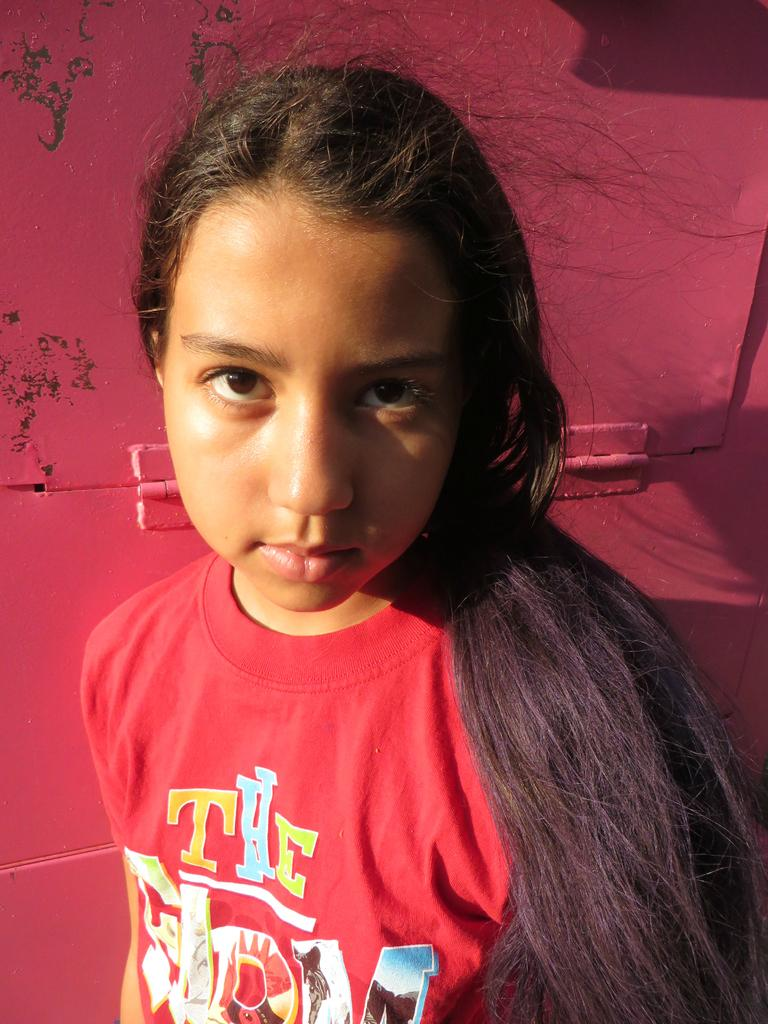<image>
Summarize the visual content of the image. A girl is wearing a red t-shirt and one of the words on it is "the". 